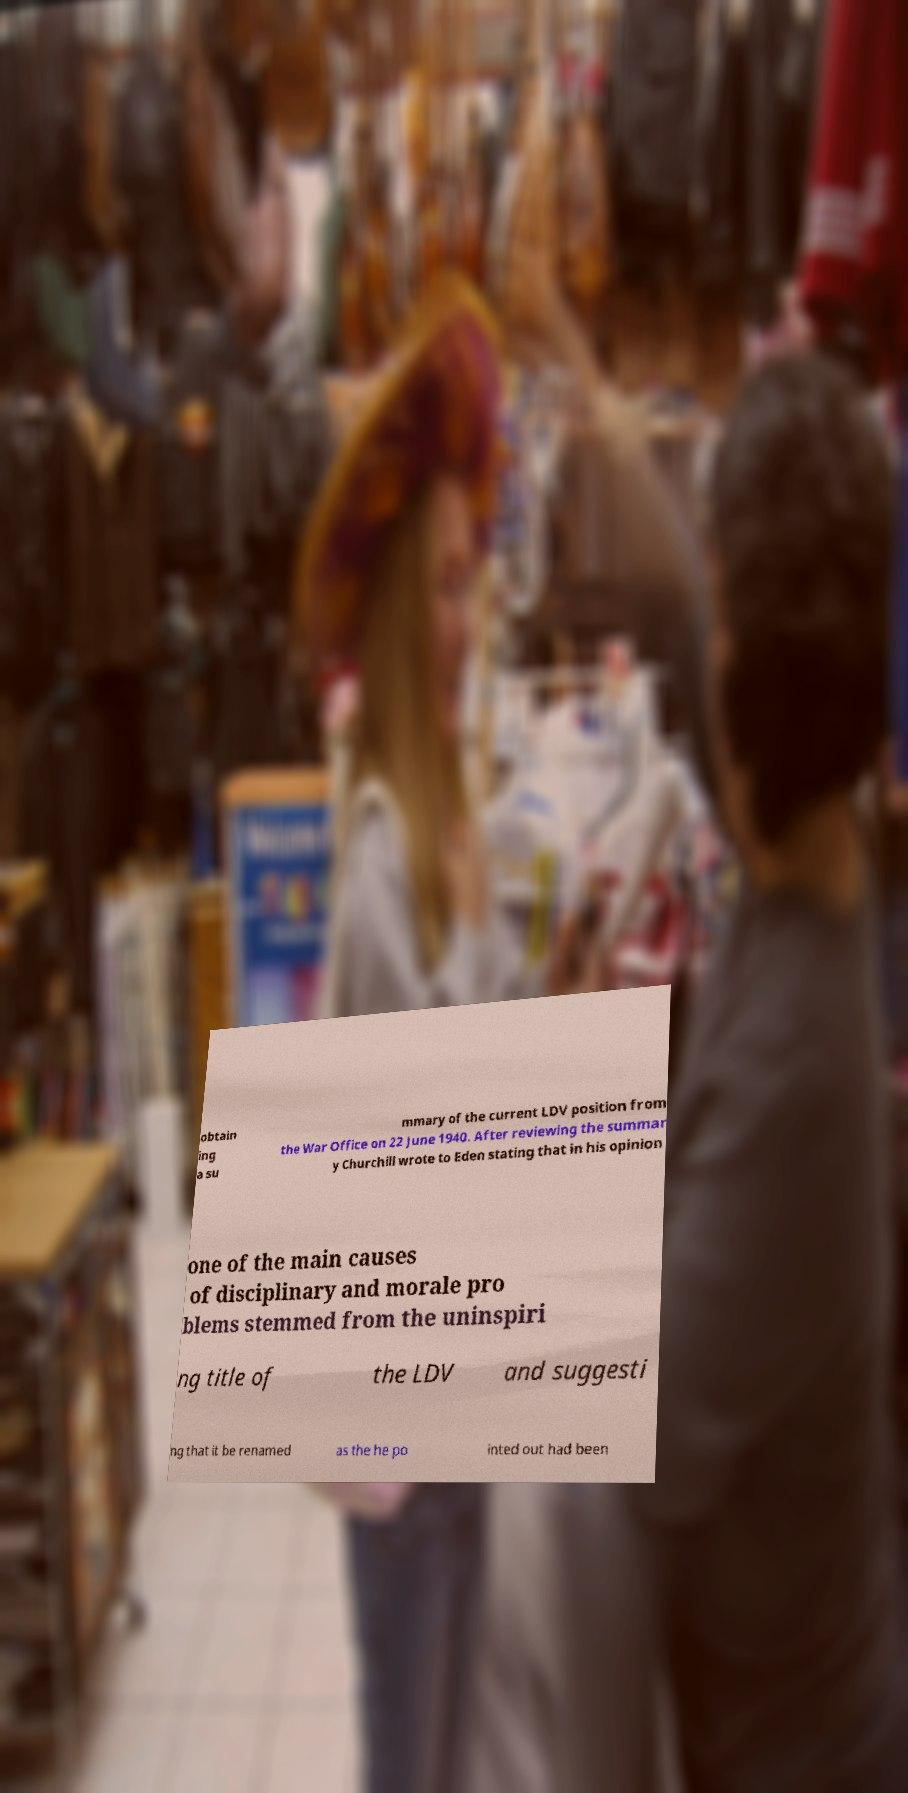I need the written content from this picture converted into text. Can you do that? obtain ing a su mmary of the current LDV position from the War Office on 22 June 1940. After reviewing the summar y Churchill wrote to Eden stating that in his opinion one of the main causes of disciplinary and morale pro blems stemmed from the uninspiri ng title of the LDV and suggesti ng that it be renamed as the he po inted out had been 